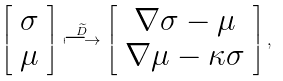<formula> <loc_0><loc_0><loc_500><loc_500>\left [ \begin{array} c \sigma \\ \mu \end{array} \right ] \stackrel { \widetilde { D } } { \longmapsto } \left [ \begin{array} c \nabla \sigma - \mu \\ \nabla \mu - \kappa \sigma \end{array} \right ] ,</formula> 